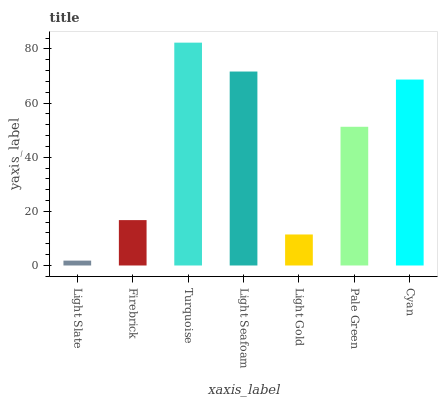Is Light Slate the minimum?
Answer yes or no. Yes. Is Turquoise the maximum?
Answer yes or no. Yes. Is Firebrick the minimum?
Answer yes or no. No. Is Firebrick the maximum?
Answer yes or no. No. Is Firebrick greater than Light Slate?
Answer yes or no. Yes. Is Light Slate less than Firebrick?
Answer yes or no. Yes. Is Light Slate greater than Firebrick?
Answer yes or no. No. Is Firebrick less than Light Slate?
Answer yes or no. No. Is Pale Green the high median?
Answer yes or no. Yes. Is Pale Green the low median?
Answer yes or no. Yes. Is Turquoise the high median?
Answer yes or no. No. Is Light Seafoam the low median?
Answer yes or no. No. 